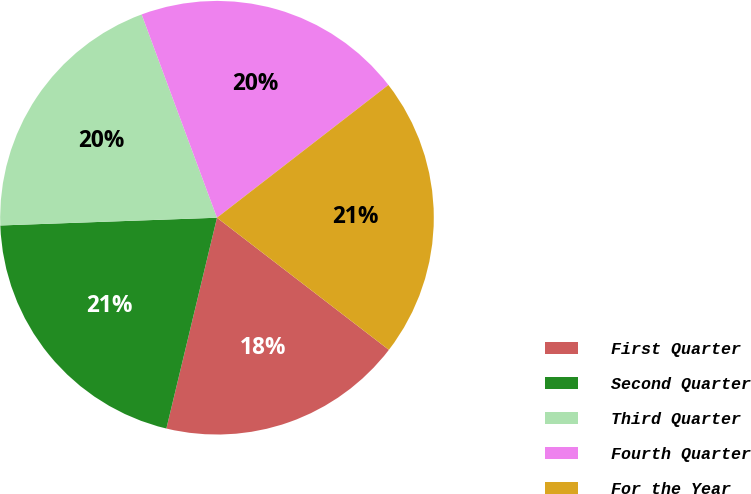<chart> <loc_0><loc_0><loc_500><loc_500><pie_chart><fcel>First Quarter<fcel>Second Quarter<fcel>Third Quarter<fcel>Fourth Quarter<fcel>For the Year<nl><fcel>18.32%<fcel>20.68%<fcel>19.92%<fcel>20.16%<fcel>20.92%<nl></chart> 